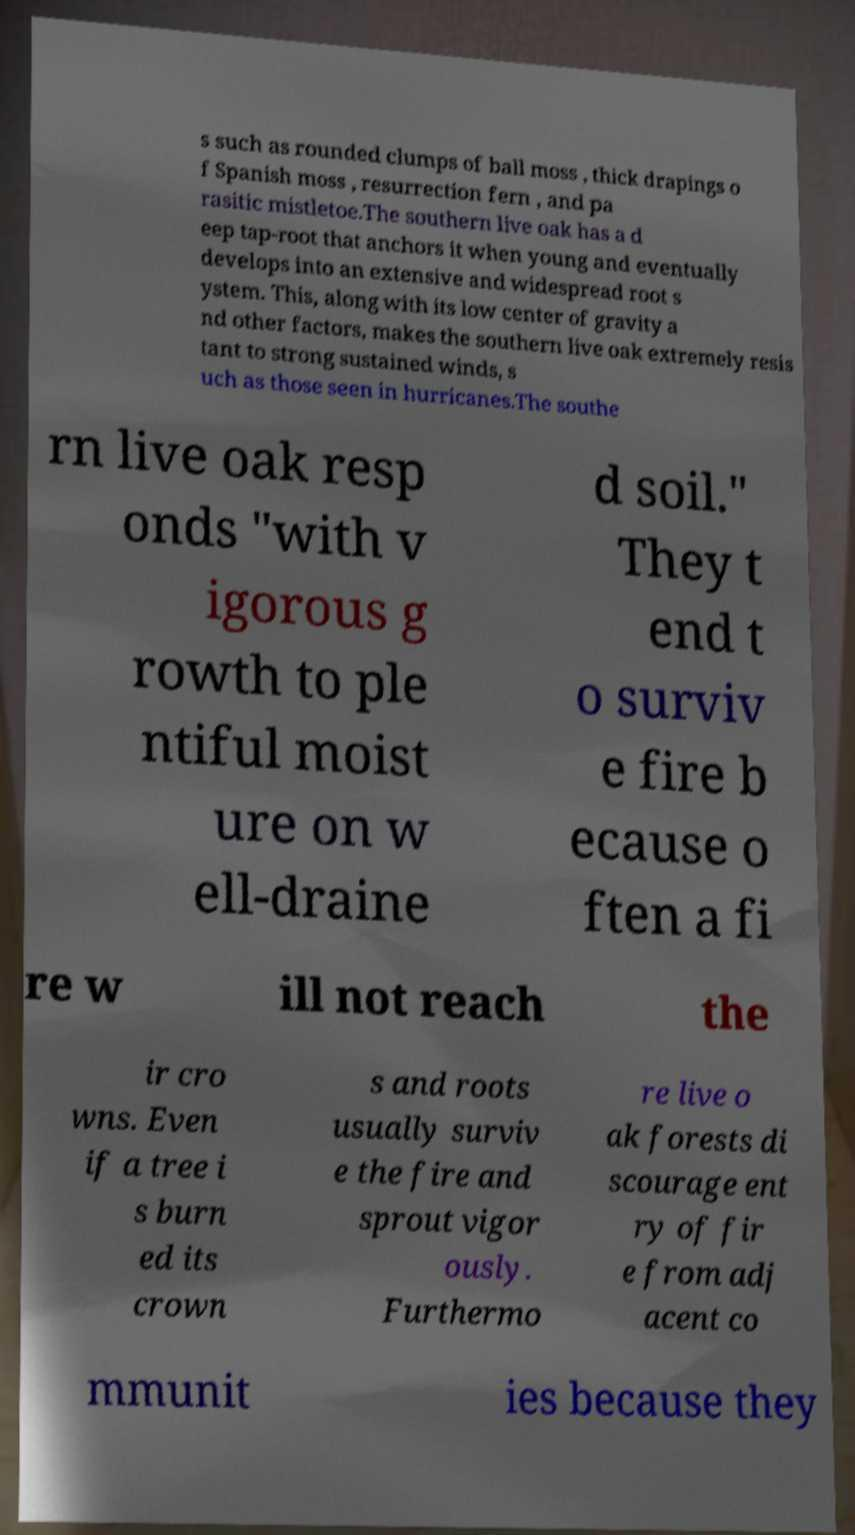I need the written content from this picture converted into text. Can you do that? s such as rounded clumps of ball moss , thick drapings o f Spanish moss , resurrection fern , and pa rasitic mistletoe.The southern live oak has a d eep tap-root that anchors it when young and eventually develops into an extensive and widespread root s ystem. This, along with its low center of gravity a nd other factors, makes the southern live oak extremely resis tant to strong sustained winds, s uch as those seen in hurricanes.The southe rn live oak resp onds "with v igorous g rowth to ple ntiful moist ure on w ell-draine d soil." They t end t o surviv e fire b ecause o ften a fi re w ill not reach the ir cro wns. Even if a tree i s burn ed its crown s and roots usually surviv e the fire and sprout vigor ously. Furthermo re live o ak forests di scourage ent ry of fir e from adj acent co mmunit ies because they 